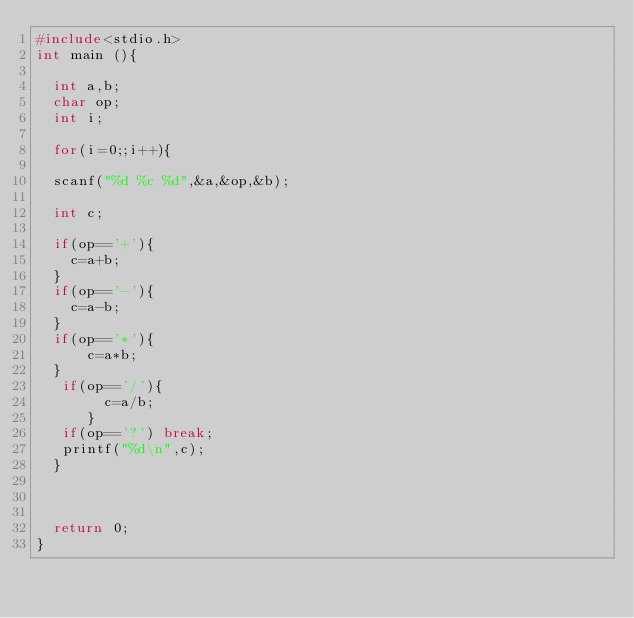Convert code to text. <code><loc_0><loc_0><loc_500><loc_500><_C_>#include<stdio.h>
int main (){

  int a,b;
  char op;
  int i;

  for(i=0;;i++){

  scanf("%d %c %d",&a,&op,&b);

  int c;

  if(op=='+'){
    c=a+b;
  }
  if(op=='-'){
    c=a-b;
  }
  if(op=='*'){
      c=a*b;
  }
   if(op=='/'){
        c=a/b;
      }
   if(op=='?') break;
   printf("%d\n",c);
  }



  return 0;
}</code> 